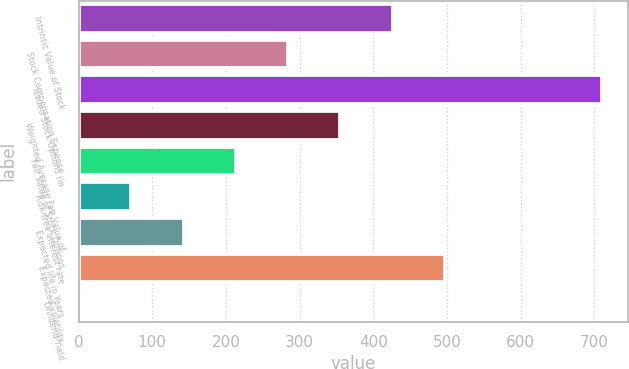Convert chart to OTSL. <chart><loc_0><loc_0><loc_500><loc_500><bar_chart><fcel>Intrinsic Value of Stock<fcel>Stock Compensation Expense<fcel>Issued Stock Options (in<fcel>Weighted Average Fair Value of<fcel>Fair Value of Stock Options<fcel>Risk-free interest rate<fcel>Expected life in Years<fcel>Expected volatility<fcel>Dividend Yield<nl><fcel>426.28<fcel>284.42<fcel>710<fcel>355.35<fcel>213.49<fcel>71.63<fcel>142.56<fcel>497.21<fcel>0.7<nl></chart> 